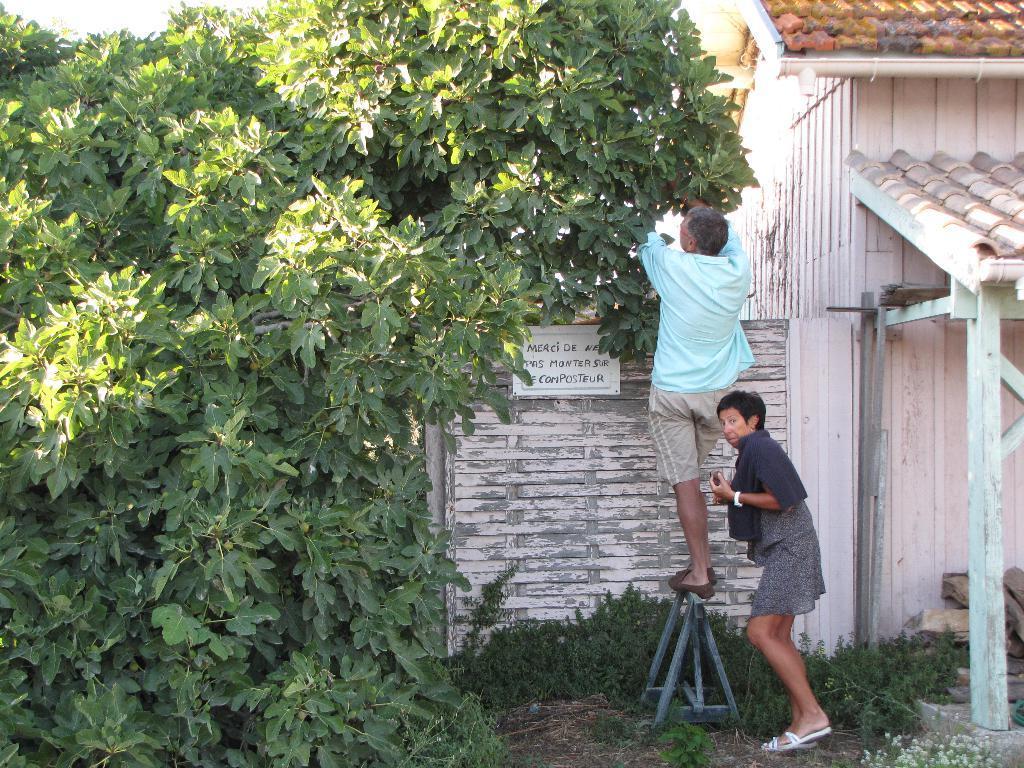How would you summarize this image in a sentence or two? This image consists of trees on the left side. There are plants at the bottom. There is a house on the right side. There are two persons in the middle. One is standing on the stool. 